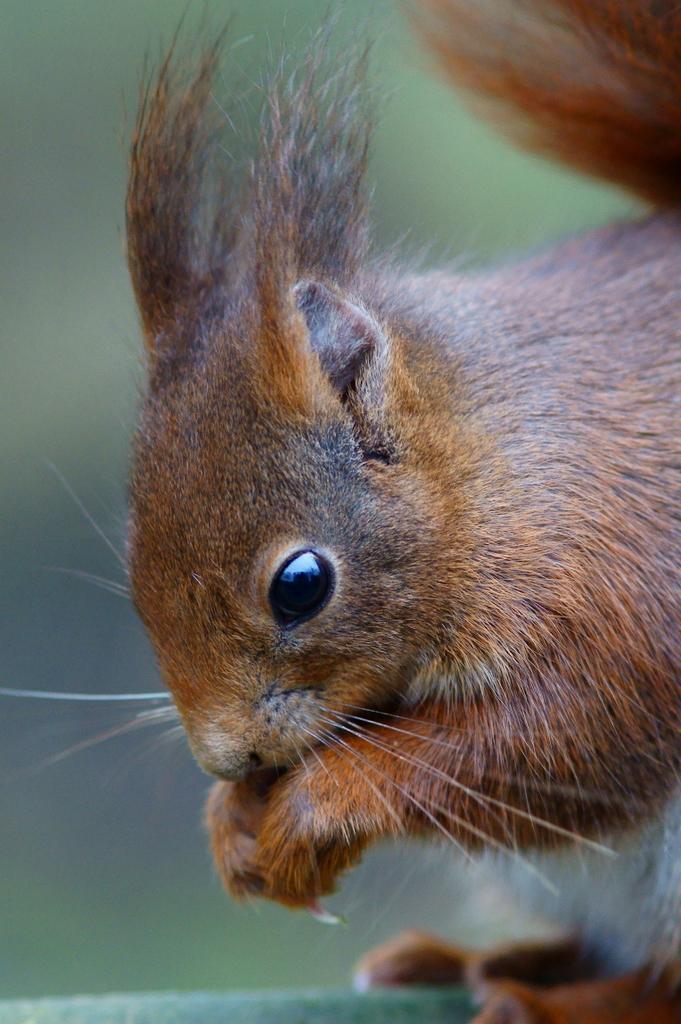Describe this image in one or two sentences. In this image I can see the squirrel in brown and black color. Background is blurred. 